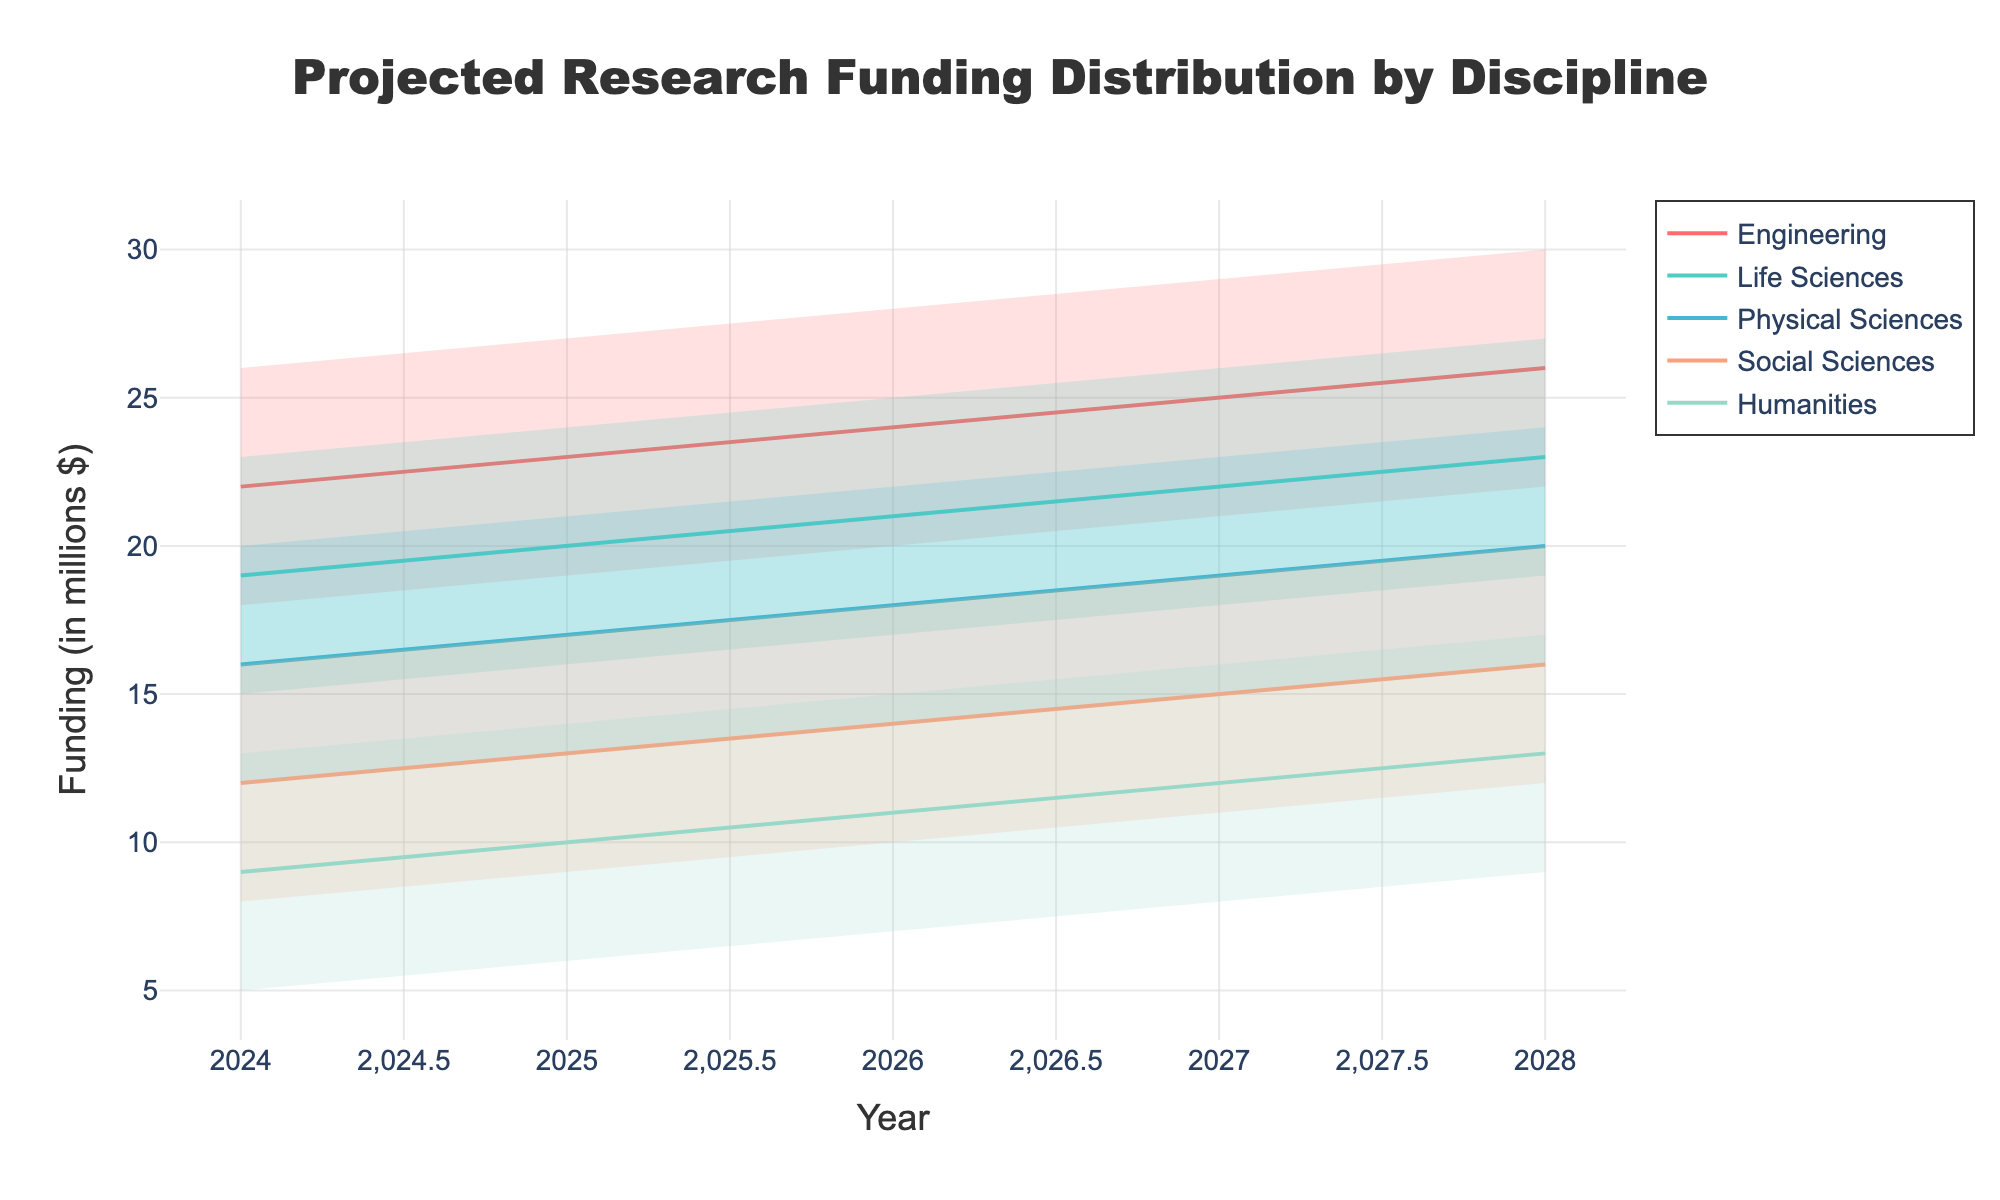What is the title of the chart? The title of the chart can be found at the top center of the figure. It reads "Projected Research Funding Distribution by Discipline".
Answer: Projected Research Funding Distribution by Discipline Which discipline has the highest median projected funding in 2026? Look at the median values for each discipline in 2026. Engineering has the highest median value, which is 24 million dollars.
Answer: Engineering In the year 2028, which disciplines' median projected funding values are closest to each other? In 2028, the median values for Life Sciences and Physical Sciences are quite close, at 23 and 20 million dollars respectively.
Answer: Life Sciences and Physical Sciences How does the median projected funding for Humanities in 2028 compare to Social Sciences in 2028? Compare the median values for Humanities and Social Sciences in 2028. Humanities has a median value of 13 million dollars, while Social Sciences has a median value of 16 million dollars.
Answer: Social Sciences is higher What trend can be observed for the median funding in Engineering from 2024 to 2028? Examining the trend line for Engineering, the median funding increases from 22 million dollars in 2024 to 26 million dollars in 2028.
Answer: Increasing What is the range of projected funding for Life Sciences in 2025? The range can be observed by subtracting the lower bound (16) from the upper bound (24) for Life Sciences in 2025, resulting in 8 million dollars.
Answer: 8 million dollars Which discipline shows the most significant spread in projected funding values in 2027? The spread is determined by the difference between the upper and lower bounds. Engineering shows the most significant spread, with values ranging from 21 to 29 million dollars.
Answer: Engineering How does the median funding for Physical Sciences change from 2024 to 2027? Compare the median values for Physical Sciences over the years 2024 to 2027. The funding increases from 16 million dollars in 2024 to 19 million dollars in 2027.
Answer: Increases Which disciplines have a median funding value of 22 million dollars in any given year? From the median funding lines, Engineering hits 22 million in 2024, Life Sciences in 2026, and there are no others with this exact value.
Answer: Engineering (2024), Life Sciences (2026) What is the overall trend for median projected funding across the disciplines from 2024 to 2028? Observing the median lines for each discipline, all show an increasing trend over the period from 2024 to 2028.
Answer: Increasing 